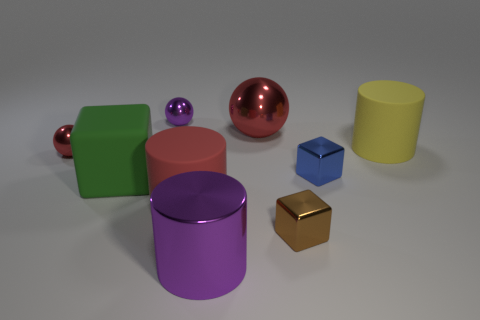Subtract all tiny blue blocks. How many blocks are left? 2 Subtract all cyan blocks. How many red spheres are left? 2 Add 1 big red balls. How many objects exist? 10 Subtract all cylinders. How many objects are left? 6 Add 7 red matte cylinders. How many red matte cylinders are left? 8 Add 7 large yellow cylinders. How many large yellow cylinders exist? 8 Subtract 0 brown cylinders. How many objects are left? 9 Subtract all gray spheres. Subtract all green cylinders. How many spheres are left? 3 Subtract all big cubes. Subtract all brown blocks. How many objects are left? 7 